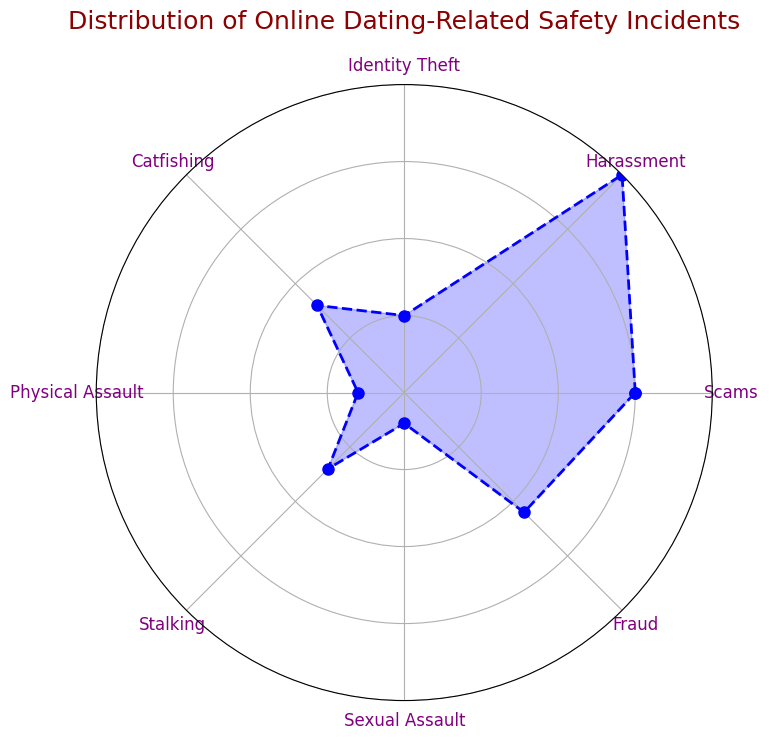What type of incident has the highest number of reports? To find the type with the highest number of reports, look for the point at the maximum distance from the center of the radar chart. The point corresponding to 'Harassment' is the farthest.
Answer: Harassment What is the difference in the number of incidents between 'Scams' and 'Identity Theft'? Locate the points for 'Scams' and 'Identity Theft' on the radar chart and subtract the number of 'Identity Theft' incidents (50) from 'Scams' incidents (150).
Answer: 100 Which type of incident has more reports, 'Catfishing' or 'Stalking'? Compare the lengths of the points for 'Catfishing' and 'Stalking'. 'Catfishing' is further out than 'Stalking', indicating more incidents.
Answer: Catfishing Is 'Fraud' closer to 'Scams' or 'Harassment' in terms of the number of incidents? Check distances from the center for 'Fraud', 'Scams', and 'Harassment'. 'Fraud' has 110 incidents, 'Scams' has 150, and 'Harassment' has 200, meaning 'Fraud' is closer to 'Scams'.
Answer: Scams What's the total number of incidents in the categories with fewer than 100 reports? Identify categories with fewer than 100 reports: 'Identity Theft' (50), 'Catfishing' (80), 'Physical Assault' (30), 'Stalking' (70), 'Sexual Assault' (20). Sum these (50 + 80 + 30 + 70 + 20).
Answer: 250 What is the average number of incidents across all categories? Add up the incidents from all categories and divide by the number of categories. The total is (150 + 200 + 50 + 80 + 30 + 70 + 20 + 110) = 710. There are 8 categories, so divide 710 by 8.
Answer: 88.75 How much more frequent are 'Harassment' incidents compared to 'Sexual Assault' incidents? Subtract the incidents of 'Sexual Assault' (20) from 'Harassment' (200).
Answer: 180 Between 'Physical Assault' and 'Stalking', which has fewer incidents, and by how much? Compare the points for 'Physical Assault' and 'Stalking'. 'Physical Assault' has 30 incidents, 'Stalking' has 70. Subtract 'Physical Assault' from 'Stalking'.
Answer: Physical Assault, 40 What's the combined number of incidents for 'Scams' and 'Fraud'? Sum the incidents for 'Scams' (150) and 'Fraud' (110).
Answer: 260 